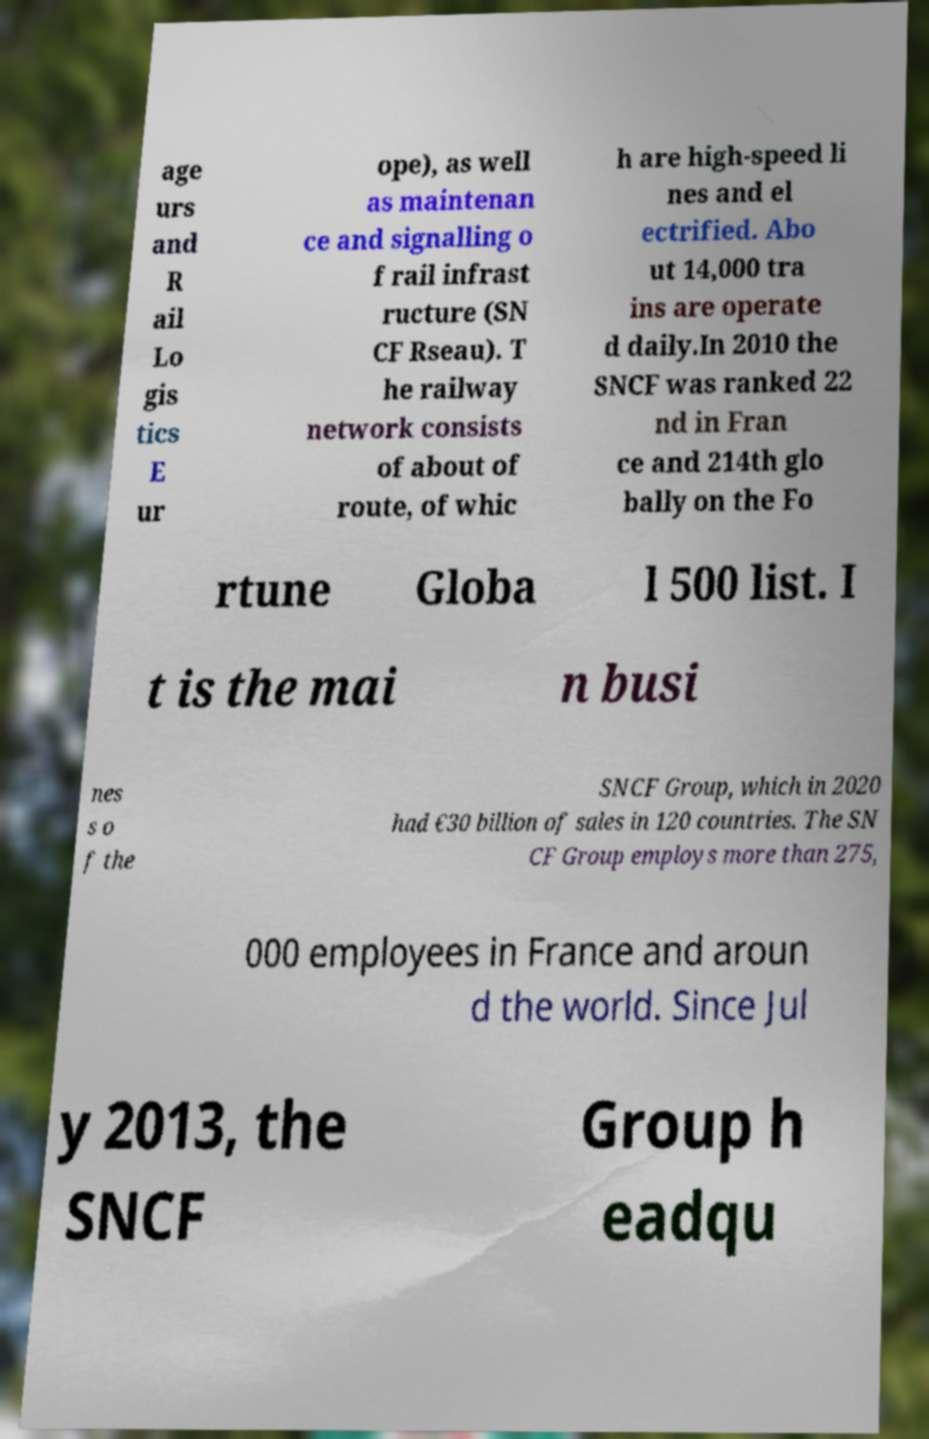Please identify and transcribe the text found in this image. age urs and R ail Lo gis tics E ur ope), as well as maintenan ce and signalling o f rail infrast ructure (SN CF Rseau). T he railway network consists of about of route, of whic h are high-speed li nes and el ectrified. Abo ut 14,000 tra ins are operate d daily.In 2010 the SNCF was ranked 22 nd in Fran ce and 214th glo bally on the Fo rtune Globa l 500 list. I t is the mai n busi nes s o f the SNCF Group, which in 2020 had €30 billion of sales in 120 countries. The SN CF Group employs more than 275, 000 employees in France and aroun d the world. Since Jul y 2013, the SNCF Group h eadqu 